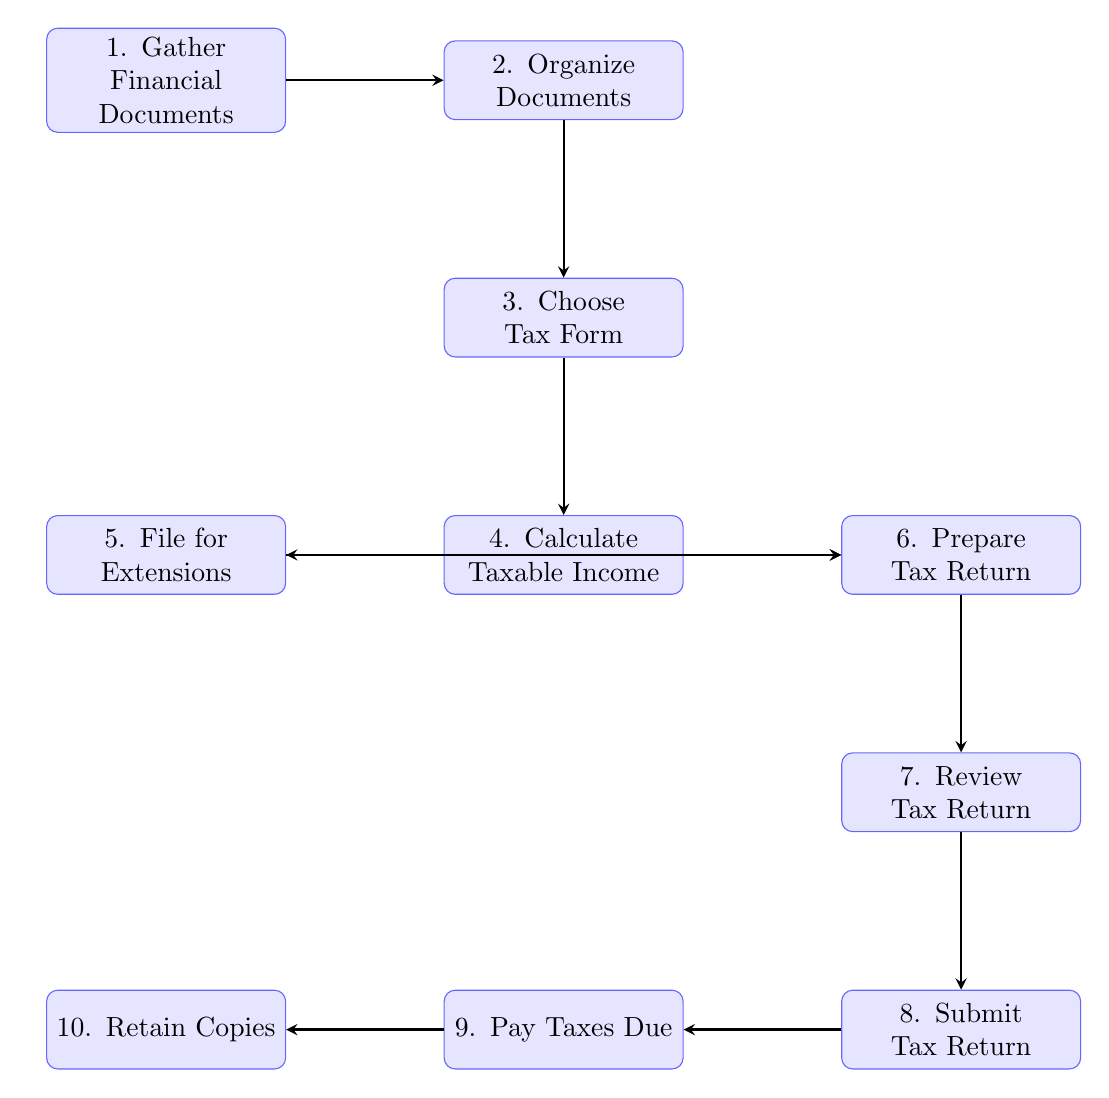What is the first step in the tax return filing process? The first node in the diagram lists "Gather Financial Documents" as the initial action to take.
Answer: Gather Financial Documents How many nodes are present in the flow chart? By counting the nodes outlined in the diagram, we find there are ten distinct steps in the process.
Answer: 10 What follows after organizing documents? The connection from the "Organize Documents" node leads directly to the "Choose Tax Form" node, indicating that selecting a tax form comes next.
Answer: Choose Tax Form What happens if more time is needed? The "File for Extensions" node indicates that filing for an extension is the appropriate action when additional time is required for tax return preparation.
Answer: File for Extensions What two actions can follow calculating taxable income? The node "Calculate Taxable Income" branches into two paths: one leads to filing for an extension and the other to preparing the tax return, showing both are possible subsequent steps.
Answer: File for Extensions, Prepare Tax Return Which step involves reviewing the tax return? The flow transitions from "Prepare Tax Return" directly to "Review Tax Return," indicating that reviewing is the next critical action after preparation.
Answer: Review Tax Return What is the last action performed in this process? The flow chart concludes with the "Retain Copies" node, confirming that keeping copies of all documents is the final step to follow after paying taxes due.
Answer: Retain Copies What is required after submitting the tax return? Following the "Submit Tax Return" node, the next required action is to "Pay Taxes Due," showing a clear chronological requirement to ensure taxes are settled.
Answer: Pay Taxes Due How do you go from filing for extensions to preparing the tax return? The connection from "File for Extensions" leads directly to "Prepare Tax Return," indicating that, after requesting more time, the next step is to prepare the return.
Answer: Prepare Tax Return 